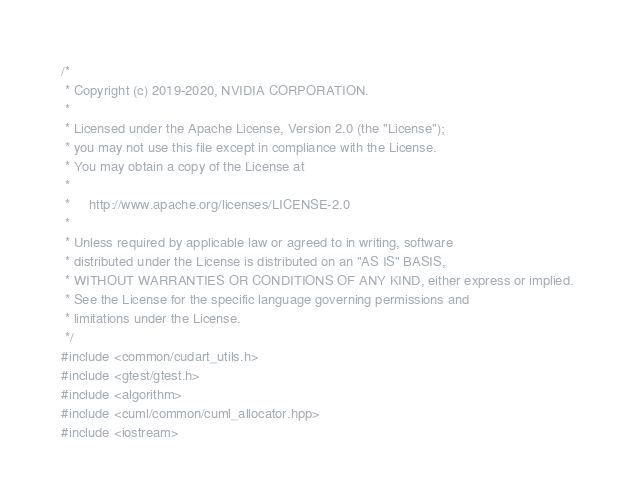<code> <loc_0><loc_0><loc_500><loc_500><_Cuda_>/*
 * Copyright (c) 2019-2020, NVIDIA CORPORATION.
 *
 * Licensed under the Apache License, Version 2.0 (the "License");
 * you may not use this file except in compliance with the License.
 * You may obtain a copy of the License at
 *
 *     http://www.apache.org/licenses/LICENSE-2.0
 *
 * Unless required by applicable law or agreed to in writing, software
 * distributed under the License is distributed on an "AS IS" BASIS,
 * WITHOUT WARRANTIES OR CONDITIONS OF ANY KIND, either express or implied.
 * See the License for the specific language governing permissions and
 * limitations under the License.
 */
#include <common/cudart_utils.h>
#include <gtest/gtest.h>
#include <algorithm>
#include <cuml/common/cuml_allocator.hpp>
#include <iostream></code> 